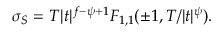Convert formula to latex. <formula><loc_0><loc_0><loc_500><loc_500>\sigma _ { S } = T | t | ^ { f - \psi + 1 } F _ { 1 , 1 } ( \pm 1 , T / | t | ^ { \psi } ) .</formula> 